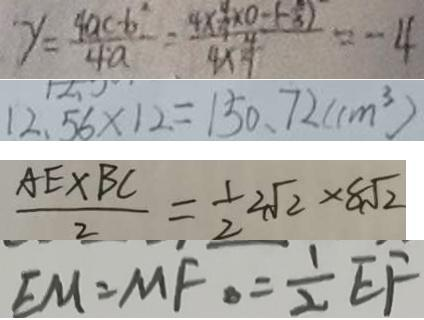<formula> <loc_0><loc_0><loc_500><loc_500>y = \frac { 4 a c - b ^ { 2 } } { 4 a } = \frac { 4 \times \frac { 4 } { 9 } \times 0 - ( - \frac { 2 } { 3 } ) } { 4 \times \frac { 4 } { 9 } } = - 4 
 1 2 . 5 6 \times 1 2 = 1 5 0 . 7 2 ( c m ^ { 3 } ) 
 \frac { A E \times B C } { 2 } = \frac { 1 } { 2 } 2 \sqrt { 2 } \times 8 \sqrt { 2 } 
 E M = M F \cdot = \frac { 1 } { 2 } E F</formula> 